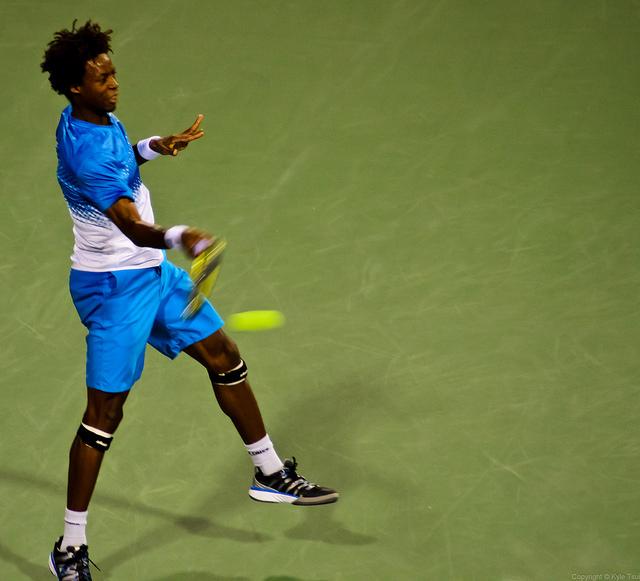Which leg does the player in white have lifted?
Quick response, please. Left. Why is there blue tape on his knee?
Short answer required. Support. Is he standing straight up and down?
Write a very short answer. Yes. Is he wearing wristbands?
Write a very short answer. Yes. How is the ground like?
Concise answer only. Hard. What color is his hair?
Short answer required. Black. 